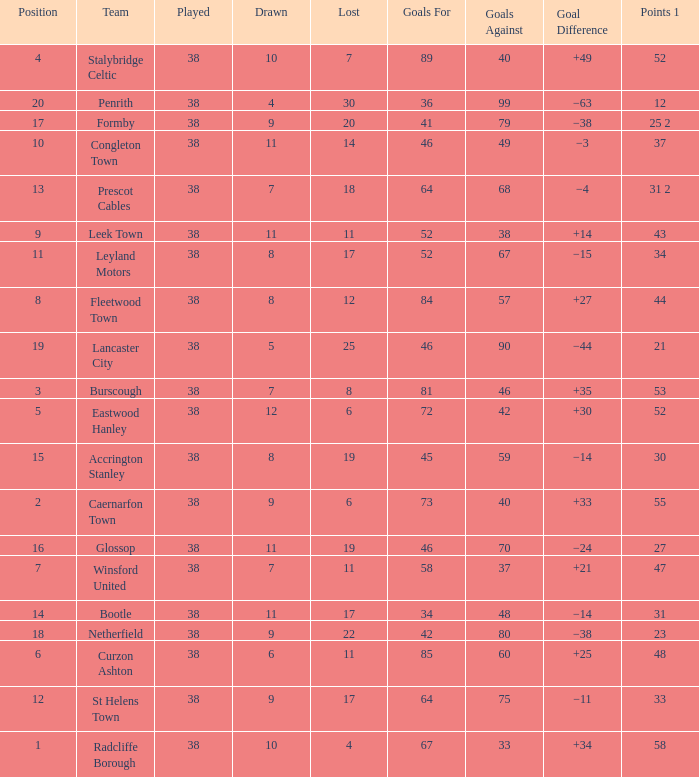WHAT GOALS AGAINST HAD A GOAL FOR OF 46, AND PLAYED LESS THAN 38? None. 